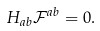Convert formula to latex. <formula><loc_0><loc_0><loc_500><loc_500>H _ { a b } \mathcal { F } ^ { a b } = 0 .</formula> 